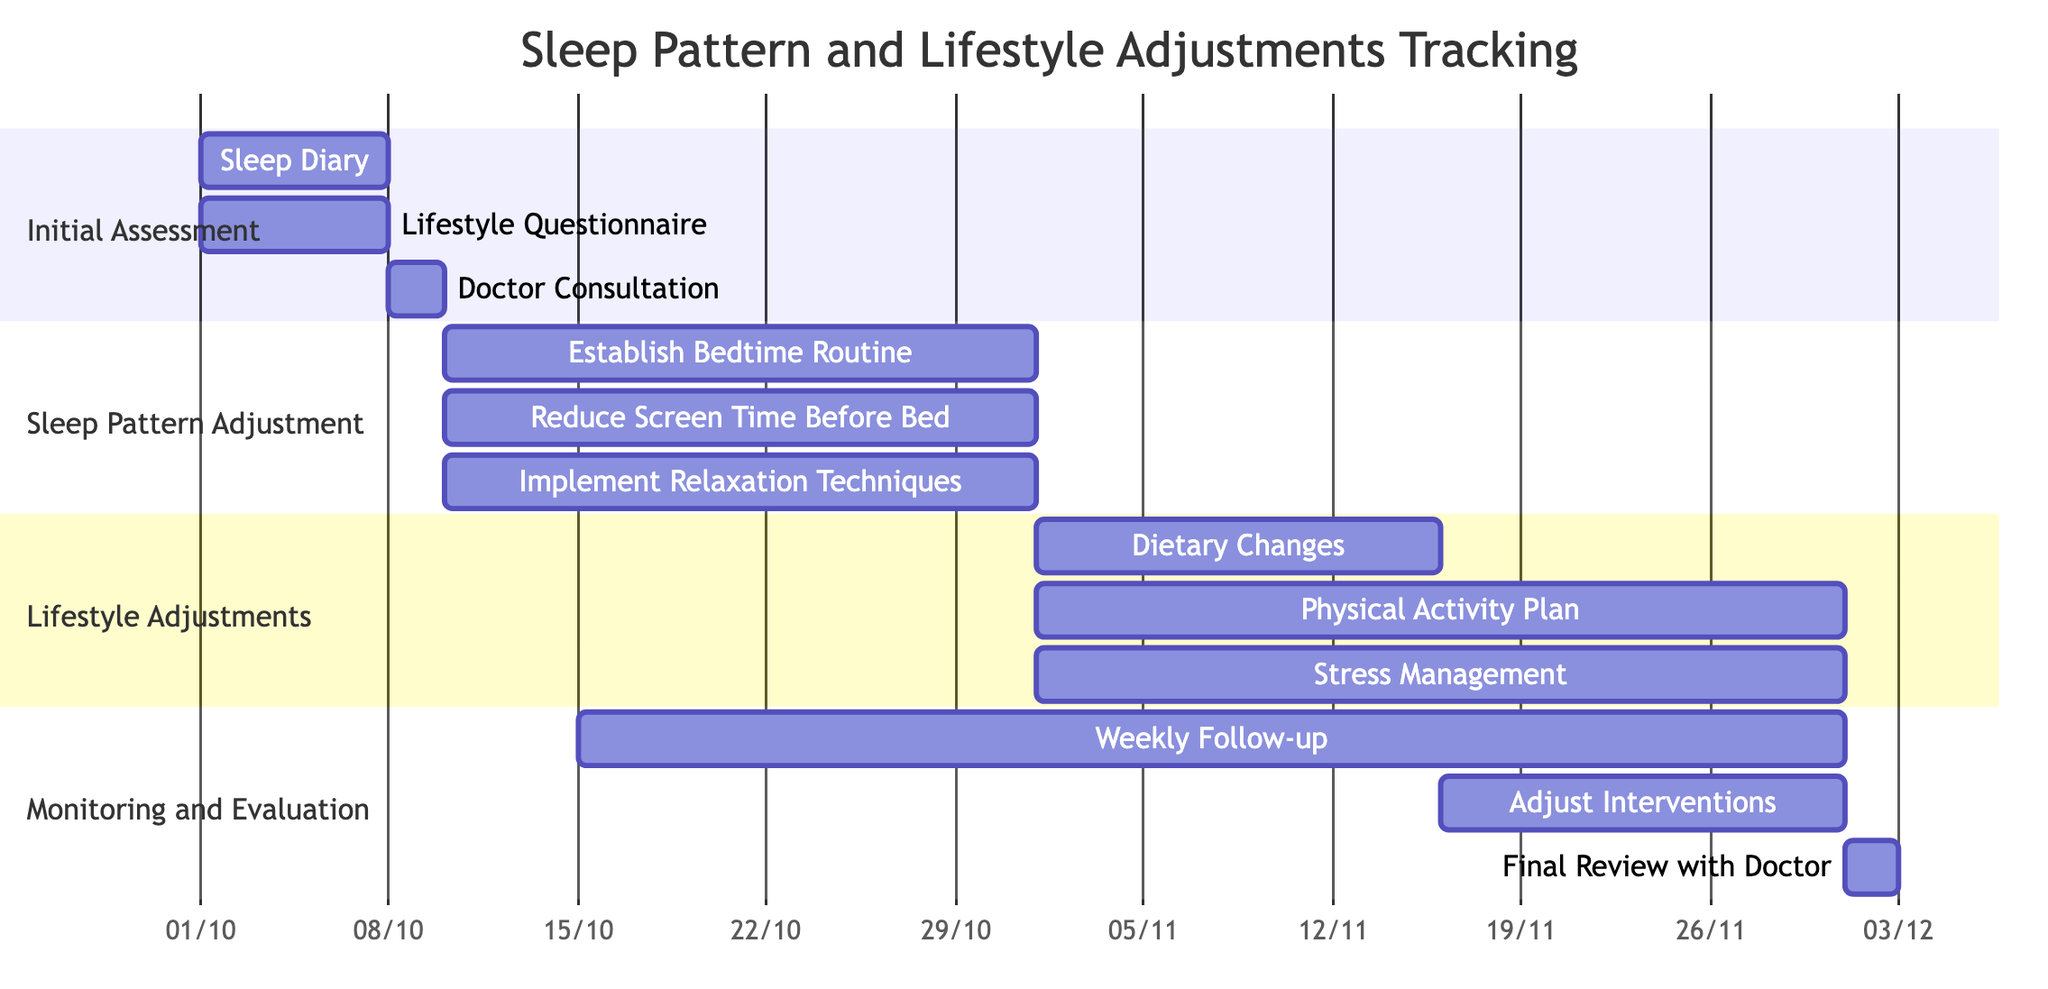What are the start and end dates for the Sleep Diary task? The Sleep Diary task starts on October 1, 2023, and ends on October 7, 2023, as indicated in the Initial Assessment section of the Gantt chart.
Answer: October 1, 2023 - October 7, 2023 How many tasks are there in the Sleep Pattern Adjustment phase? The Sleep Pattern Adjustment phase contains three tasks: Establish Bedtime Routine, Reduce Screen Time Before Bed, and Implement Relaxation Techniques.
Answer: Three Which task has the latest end date? To find the latest end date, we compare the end dates of all tasks in the diagram. The Weekly Follow-up task ends on November 30, 2023, which is the latest date compared to others.
Answer: November 30, 2023 What is the duration of the Dietary Changes task? The Dietary Changes task starts on November 1, 2023, and ends on November 15, 2023. To calculate its duration, we count the number of days: 15 - 1 + 1 = 15 days.
Answer: 15 days When does the Final Review with Doctor occur? The Final Review with Doctor task occurs from December 1, 2023, to December 2, 2023, as shown in the Monitoring and Evaluation section of the Gantt chart.
Answer: December 1, 2023 - December 2, 2023 How long is the overlap between the Weekly Follow-up and Dietary Changes tasks? The Weekly Follow-up starts on October 15, 2023, and continues until November 30, 2023. The Dietary Changes task starts on November 1, 2023, and ends on November 15, 2023. They overlap from November 1 to November 15, which is 15 days total in duration.
Answer: 15 days 